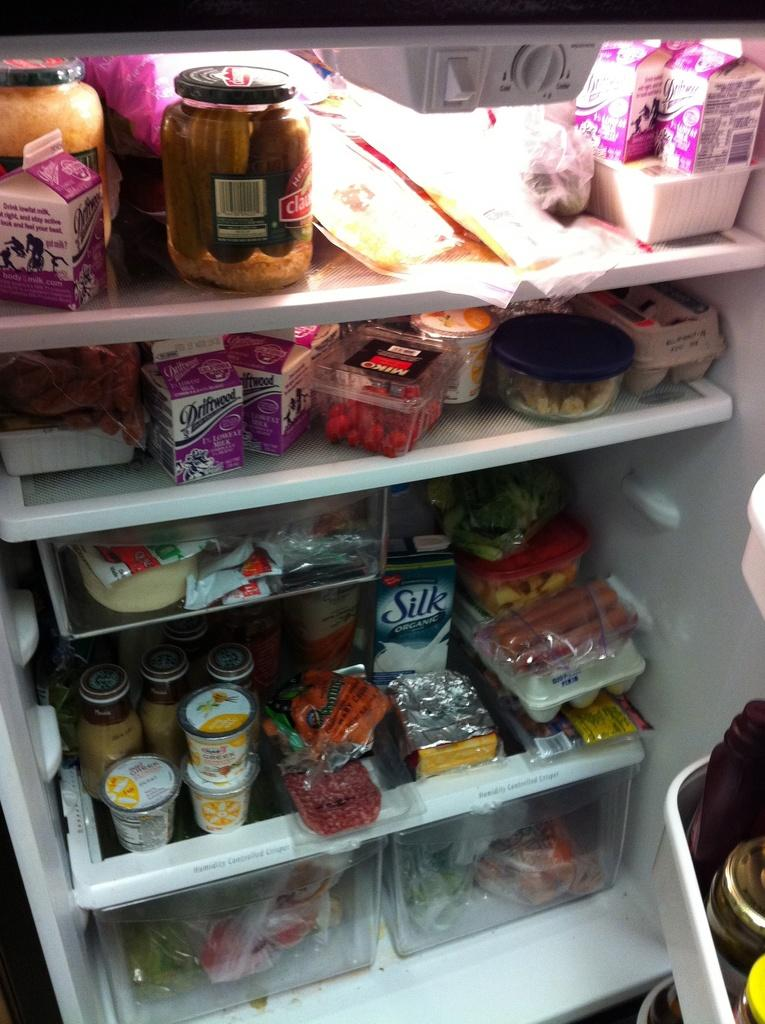<image>
Share a concise interpretation of the image provided. Refrigerator full of food including an organic Silk soymilk on the bottom. 